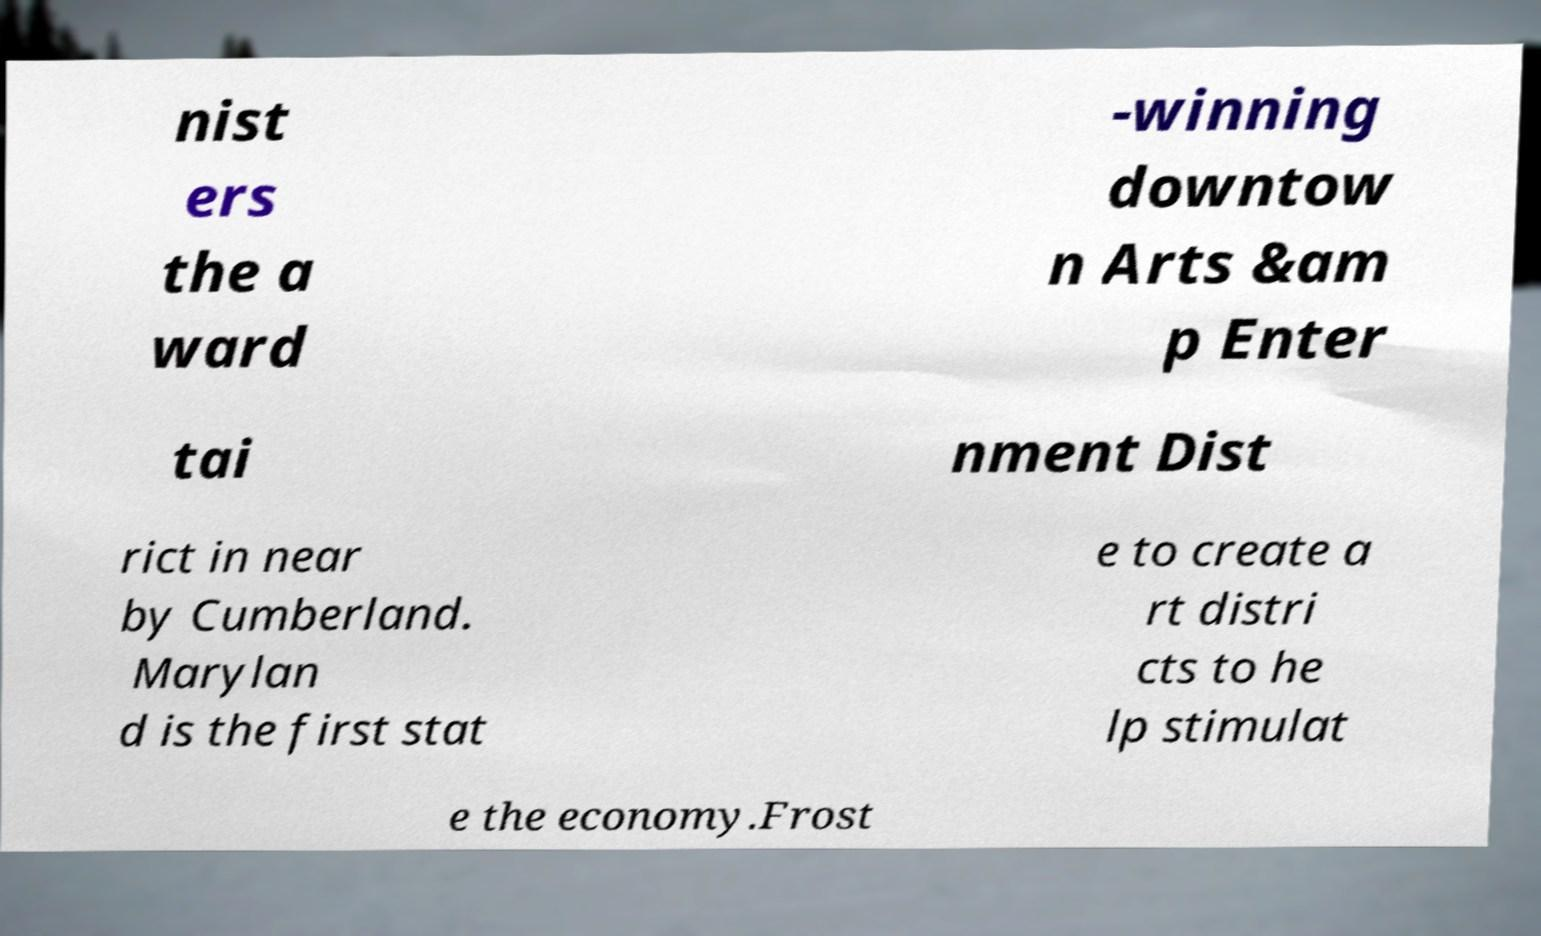What messages or text are displayed in this image? I need them in a readable, typed format. nist ers the a ward -winning downtow n Arts &am p Enter tai nment Dist rict in near by Cumberland. Marylan d is the first stat e to create a rt distri cts to he lp stimulat e the economy.Frost 